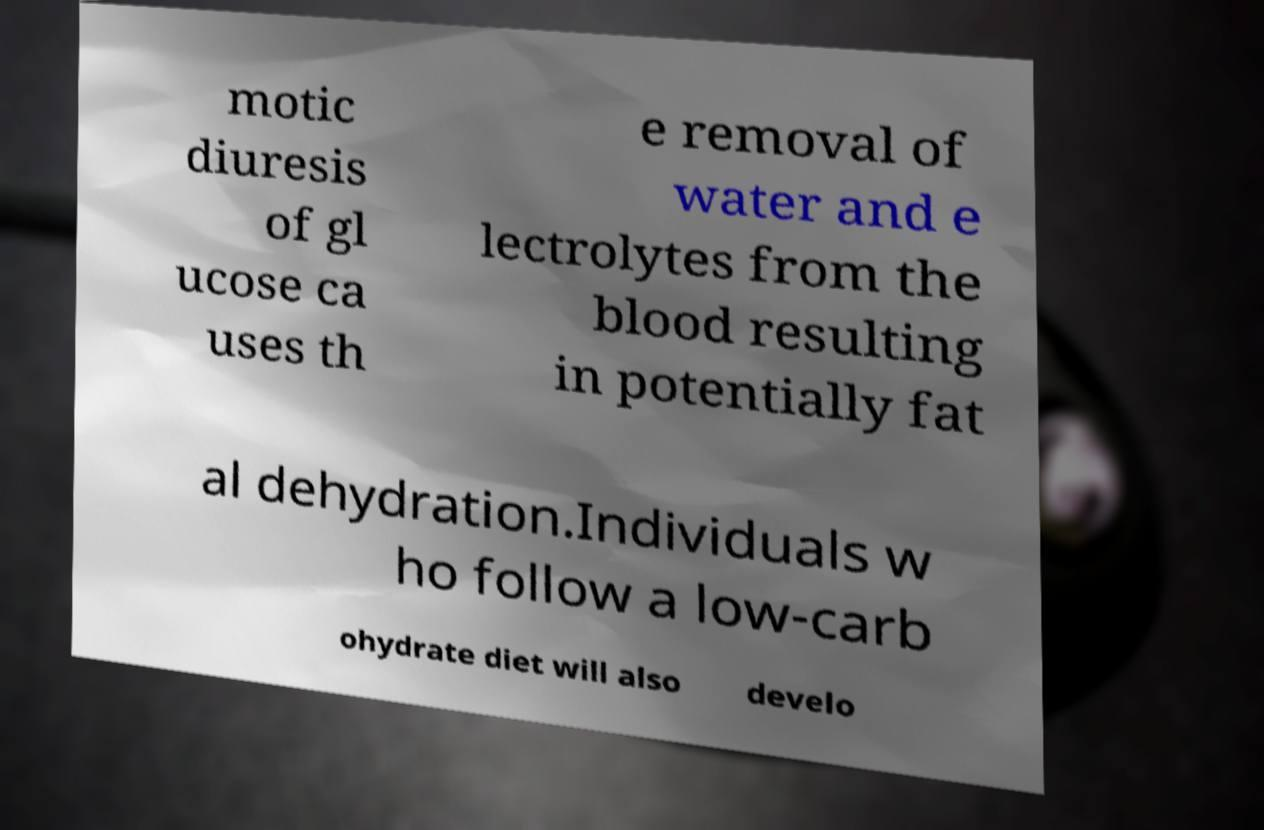Please identify and transcribe the text found in this image. motic diuresis of gl ucose ca uses th e removal of water and e lectrolytes from the blood resulting in potentially fat al dehydration.Individuals w ho follow a low-carb ohydrate diet will also develo 